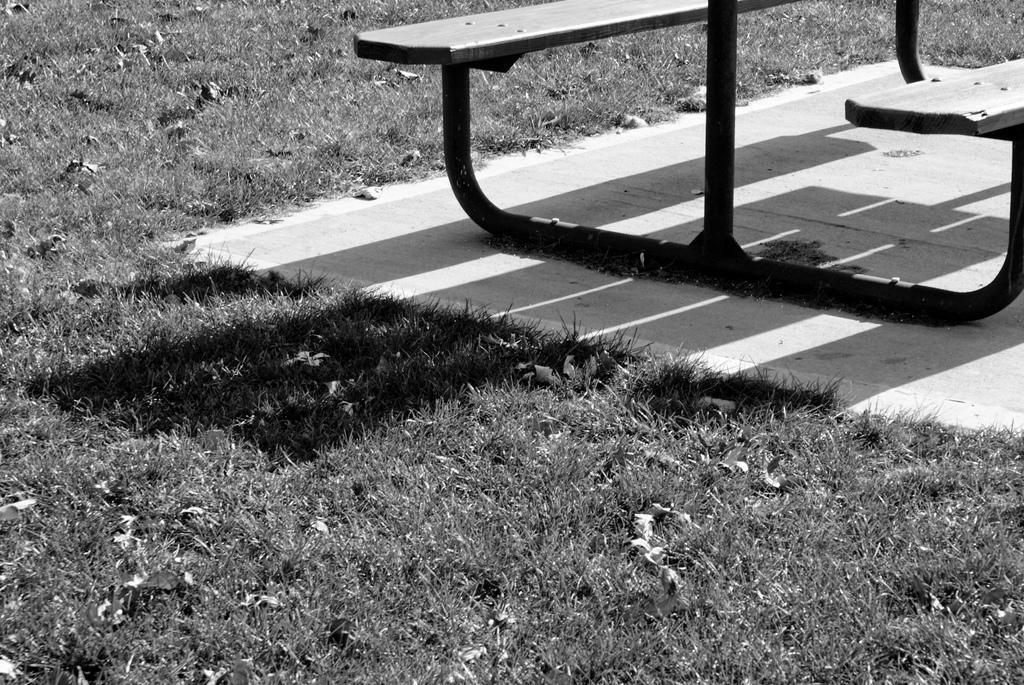In one or two sentences, can you explain what this image depicts? In this image I can see grass, a bench, shadow and I can see this image is black and white in colour. 